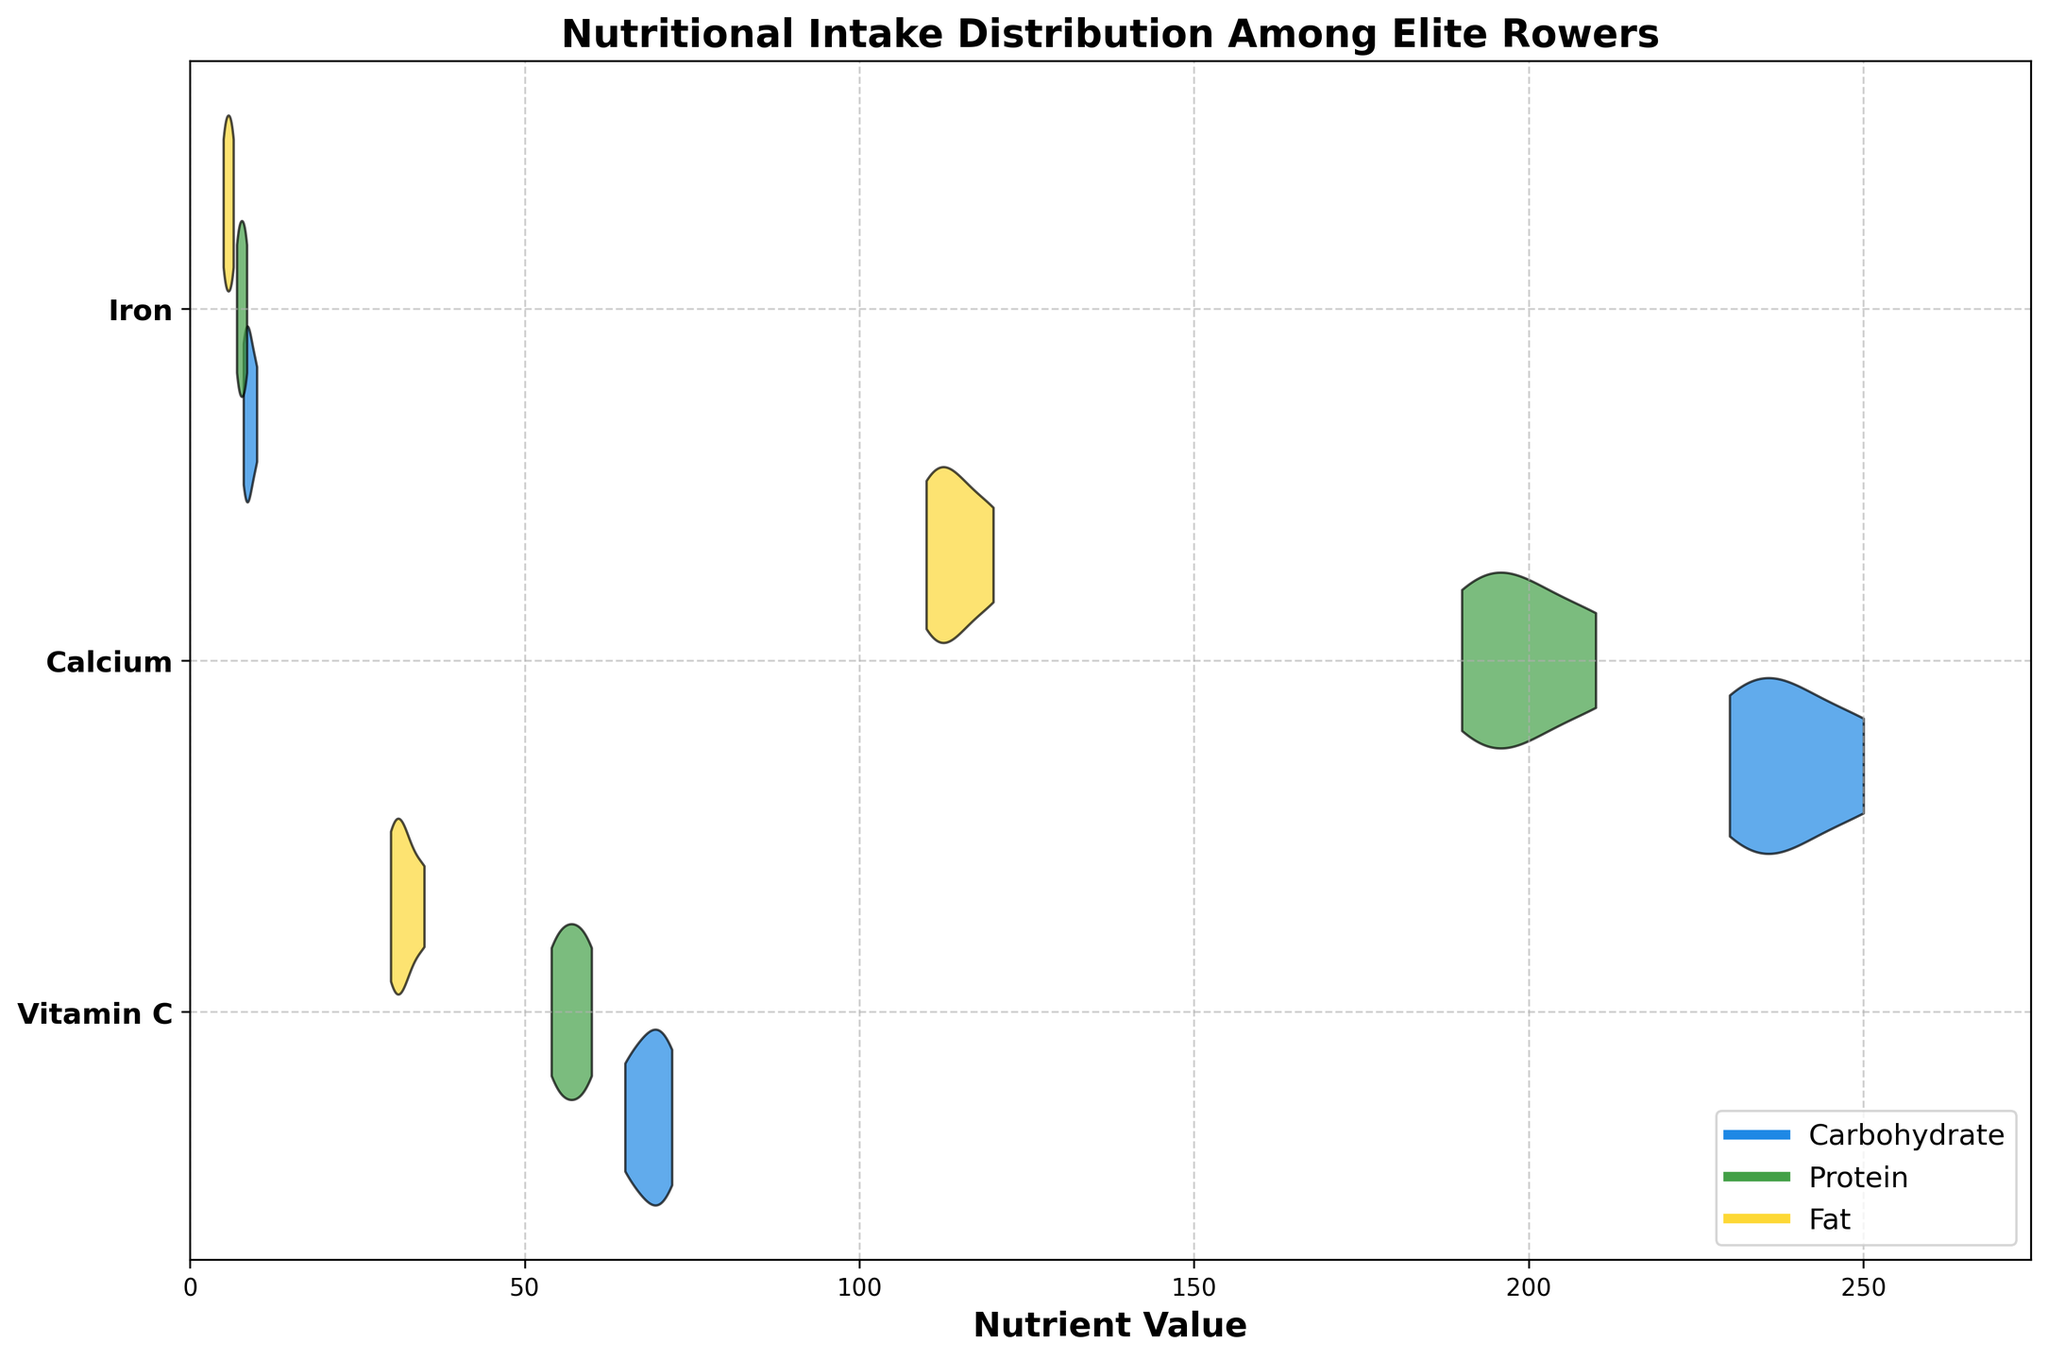What is the title of the figure? The title is placed at the top of the figure, indicating the overall theme or subject of the chart. This helps in quickly understanding what the chart represents.
Answer: Nutritional Intake Distribution Among Elite Rowers Which macronutrient appears in blue? The legend at the bottom right of the figure shows the color coding for each macronutrient. The macronutrient with the blue color according to the legend is Carbohydrate.
Answer: Carbohydrate For which micronutrient do Protein and Fat have the same range of values? By observing the horizontal distributions of each micronutrient, we can see that the areas representing Protein and Fat overlap visually.
Answer: Iron Which macronutrient has the widest range for Vitamin C? By comparing the horizontal extent of each macronutrient’s violin plot for Vitamin C, we can see which one spans the largest value range. Protein's distribution seems to span the widest range.
Answer: Protein Do Carbohydrate and Protein have overlapping distributions for Calcium? By looking at the horizontal distributions for Carbohydrate and Protein along the y-axis for Calcium, we check if the areas overlap or intersect.
Answer: Yes Which micronutrient has the highest median value across all macronutrients? By identifying the thickest center point of the violin in each section and comparing them, we look for the highest median point. Calcium generally has a higher central point than Vitamin C and Iron.
Answer: Calcium Between Carbohydrate and Fat, which one has a higher average value for Vitamin C? Observing the central tendency and concentration of values for the horizontal distributions of both Carbohydrate and Fat in the Vitamin C section helps determine the higher average. Carbohydrate's distribution seems centered around higher values.
Answer: Carbohydrate Which macronutrient has the most consistent (least spread) distribution for Iron? By assessing the width and spread of the violin plot, the one with the narrowest shape indicates the most consistent distribution. Fat appears to have the least spread for Iron.
Answer: Fat If we compare Carbohydrate and Protein for Iron, which has a higher maximum value? By identifying the maximum extent of the rightward spread for the distributions of Carbohydrate and Protein in the Iron section, we see which one extends further right. Carbohydrate's distribution extends further.
Answer: Carbohydrate What is the primary insight gained from this chart about elite rowers' nutritional intake? The chart was designed to illustrate the distribution and variation of macronutrient intakes across different micronutrients, showing patterns, consistency, or differences in dietary components among elite rowers.
Answer: Macronutrient distributions vary significantly across different micronutrients, indicating diverse dietary compositions 